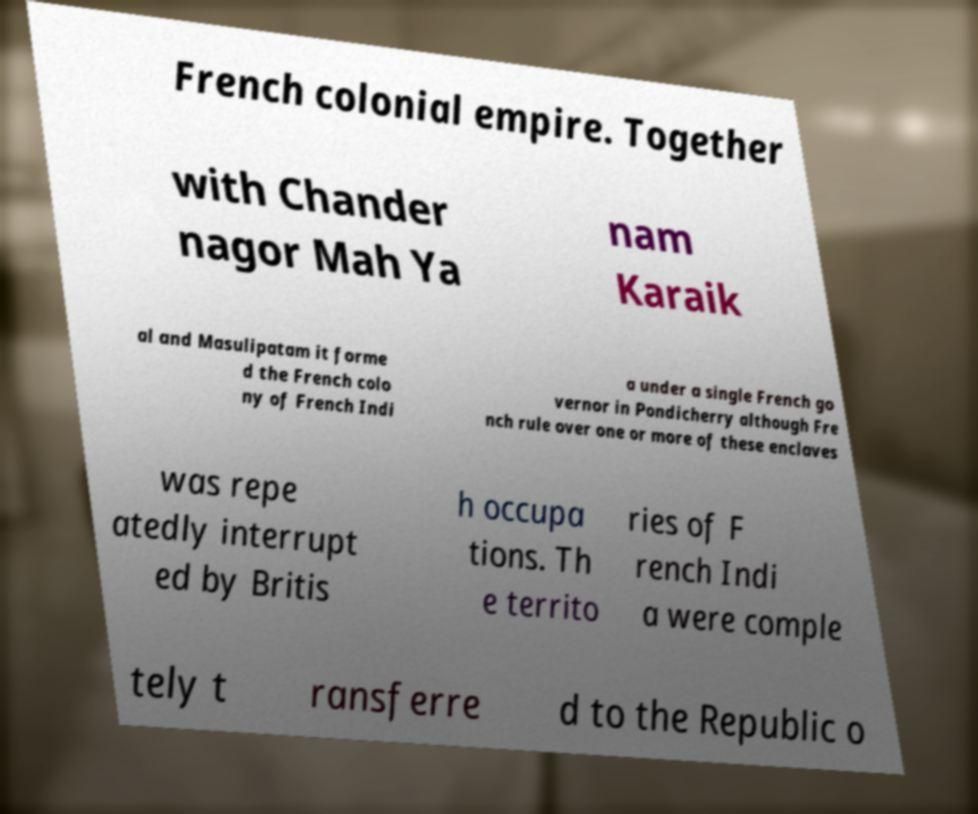Could you extract and type out the text from this image? French colonial empire. Together with Chander nagor Mah Ya nam Karaik al and Masulipatam it forme d the French colo ny of French Indi a under a single French go vernor in Pondicherry although Fre nch rule over one or more of these enclaves was repe atedly interrupt ed by Britis h occupa tions. Th e territo ries of F rench Indi a were comple tely t ransferre d to the Republic o 